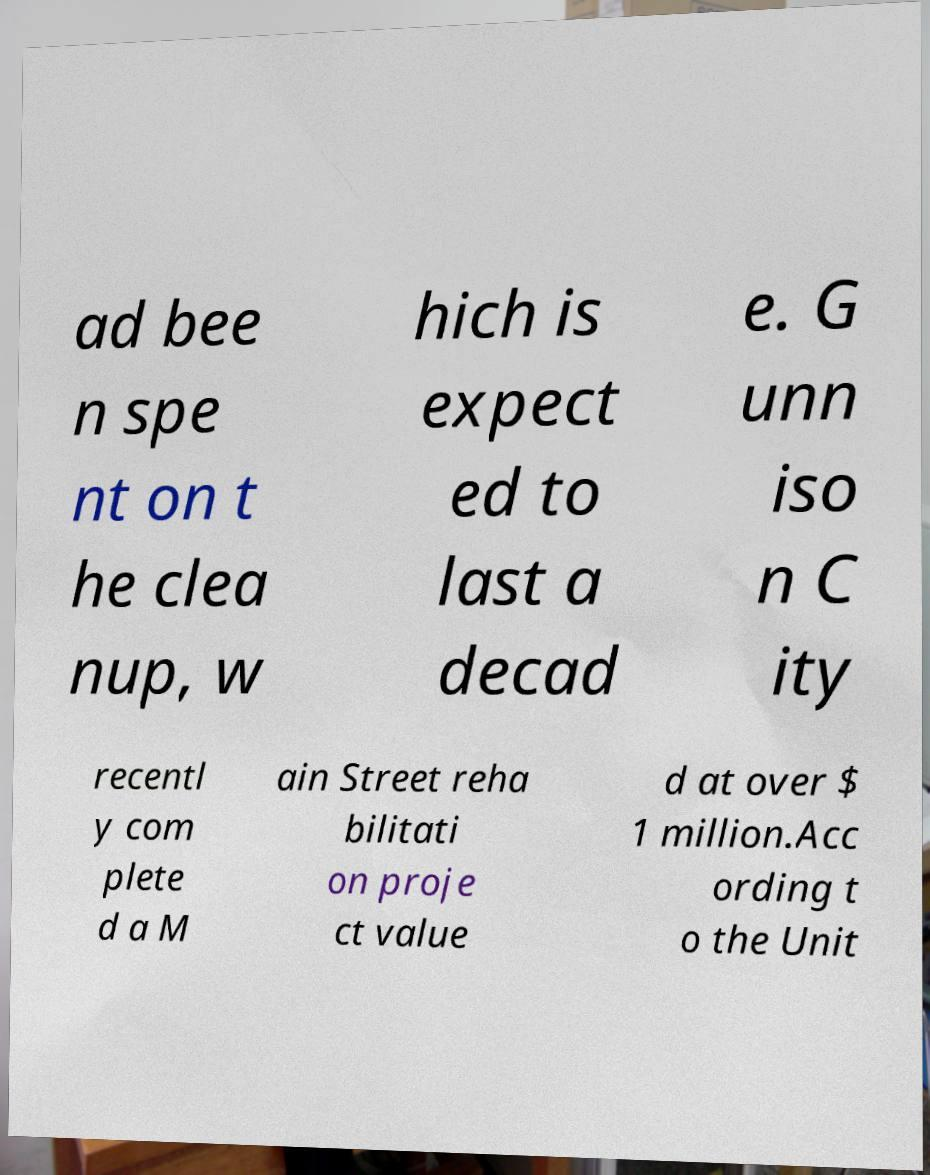I need the written content from this picture converted into text. Can you do that? ad bee n spe nt on t he clea nup, w hich is expect ed to last a decad e. G unn iso n C ity recentl y com plete d a M ain Street reha bilitati on proje ct value d at over $ 1 million.Acc ording t o the Unit 